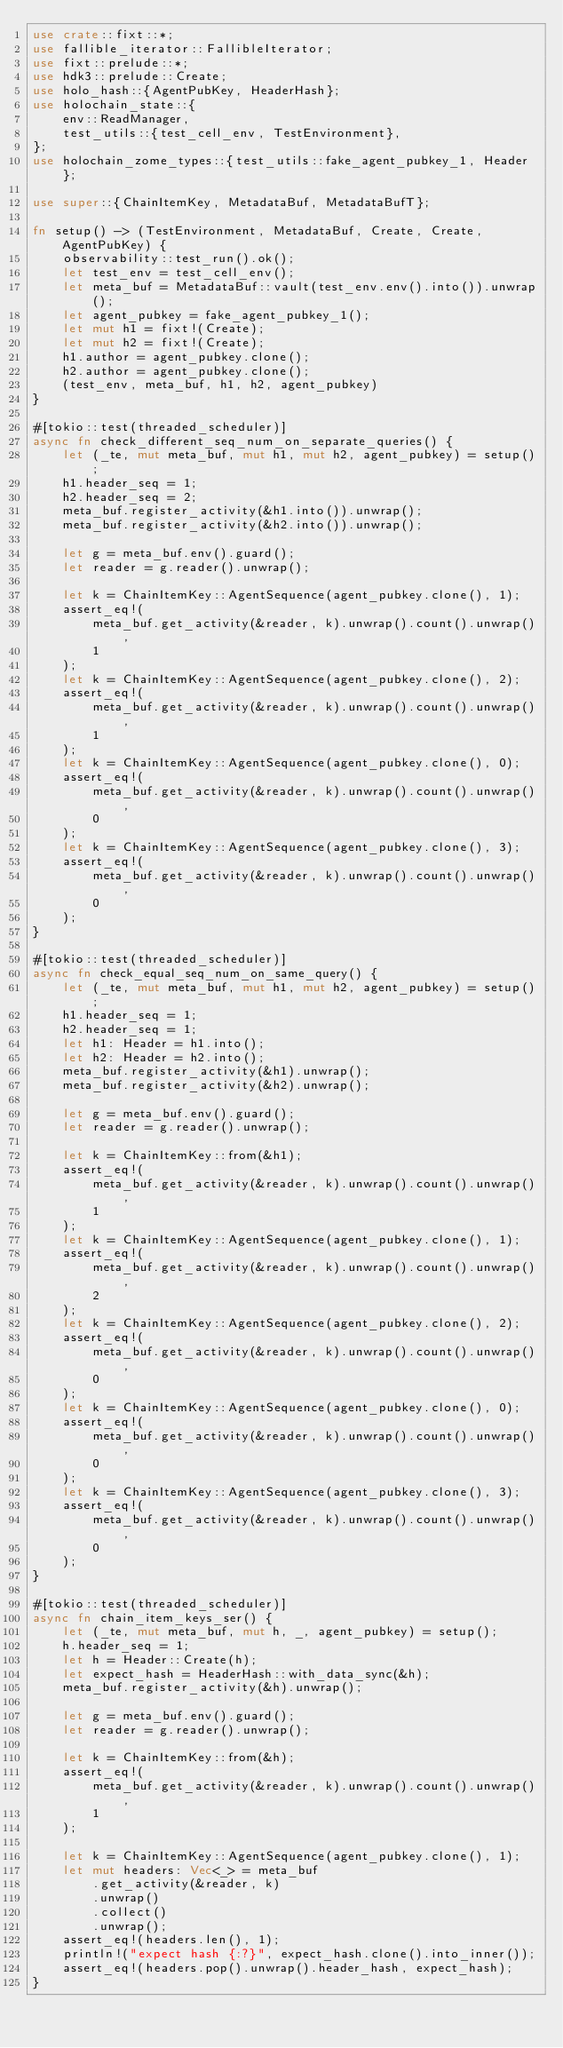<code> <loc_0><loc_0><loc_500><loc_500><_Rust_>use crate::fixt::*;
use fallible_iterator::FallibleIterator;
use fixt::prelude::*;
use hdk3::prelude::Create;
use holo_hash::{AgentPubKey, HeaderHash};
use holochain_state::{
    env::ReadManager,
    test_utils::{test_cell_env, TestEnvironment},
};
use holochain_zome_types::{test_utils::fake_agent_pubkey_1, Header};

use super::{ChainItemKey, MetadataBuf, MetadataBufT};

fn setup() -> (TestEnvironment, MetadataBuf, Create, Create, AgentPubKey) {
    observability::test_run().ok();
    let test_env = test_cell_env();
    let meta_buf = MetadataBuf::vault(test_env.env().into()).unwrap();
    let agent_pubkey = fake_agent_pubkey_1();
    let mut h1 = fixt!(Create);
    let mut h2 = fixt!(Create);
    h1.author = agent_pubkey.clone();
    h2.author = agent_pubkey.clone();
    (test_env, meta_buf, h1, h2, agent_pubkey)
}

#[tokio::test(threaded_scheduler)]
async fn check_different_seq_num_on_separate_queries() {
    let (_te, mut meta_buf, mut h1, mut h2, agent_pubkey) = setup();
    h1.header_seq = 1;
    h2.header_seq = 2;
    meta_buf.register_activity(&h1.into()).unwrap();
    meta_buf.register_activity(&h2.into()).unwrap();

    let g = meta_buf.env().guard();
    let reader = g.reader().unwrap();

    let k = ChainItemKey::AgentSequence(agent_pubkey.clone(), 1);
    assert_eq!(
        meta_buf.get_activity(&reader, k).unwrap().count().unwrap(),
        1
    );
    let k = ChainItemKey::AgentSequence(agent_pubkey.clone(), 2);
    assert_eq!(
        meta_buf.get_activity(&reader, k).unwrap().count().unwrap(),
        1
    );
    let k = ChainItemKey::AgentSequence(agent_pubkey.clone(), 0);
    assert_eq!(
        meta_buf.get_activity(&reader, k).unwrap().count().unwrap(),
        0
    );
    let k = ChainItemKey::AgentSequence(agent_pubkey.clone(), 3);
    assert_eq!(
        meta_buf.get_activity(&reader, k).unwrap().count().unwrap(),
        0
    );
}

#[tokio::test(threaded_scheduler)]
async fn check_equal_seq_num_on_same_query() {
    let (_te, mut meta_buf, mut h1, mut h2, agent_pubkey) = setup();
    h1.header_seq = 1;
    h2.header_seq = 1;
    let h1: Header = h1.into();
    let h2: Header = h2.into();
    meta_buf.register_activity(&h1).unwrap();
    meta_buf.register_activity(&h2).unwrap();

    let g = meta_buf.env().guard();
    let reader = g.reader().unwrap();

    let k = ChainItemKey::from(&h1);
    assert_eq!(
        meta_buf.get_activity(&reader, k).unwrap().count().unwrap(),
        1
    );
    let k = ChainItemKey::AgentSequence(agent_pubkey.clone(), 1);
    assert_eq!(
        meta_buf.get_activity(&reader, k).unwrap().count().unwrap(),
        2
    );
    let k = ChainItemKey::AgentSequence(agent_pubkey.clone(), 2);
    assert_eq!(
        meta_buf.get_activity(&reader, k).unwrap().count().unwrap(),
        0
    );
    let k = ChainItemKey::AgentSequence(agent_pubkey.clone(), 0);
    assert_eq!(
        meta_buf.get_activity(&reader, k).unwrap().count().unwrap(),
        0
    );
    let k = ChainItemKey::AgentSequence(agent_pubkey.clone(), 3);
    assert_eq!(
        meta_buf.get_activity(&reader, k).unwrap().count().unwrap(),
        0
    );
}

#[tokio::test(threaded_scheduler)]
async fn chain_item_keys_ser() {
    let (_te, mut meta_buf, mut h, _, agent_pubkey) = setup();
    h.header_seq = 1;
    let h = Header::Create(h);
    let expect_hash = HeaderHash::with_data_sync(&h);
    meta_buf.register_activity(&h).unwrap();

    let g = meta_buf.env().guard();
    let reader = g.reader().unwrap();

    let k = ChainItemKey::from(&h);
    assert_eq!(
        meta_buf.get_activity(&reader, k).unwrap().count().unwrap(),
        1
    );

    let k = ChainItemKey::AgentSequence(agent_pubkey.clone(), 1);
    let mut headers: Vec<_> = meta_buf
        .get_activity(&reader, k)
        .unwrap()
        .collect()
        .unwrap();
    assert_eq!(headers.len(), 1);
    println!("expect hash {:?}", expect_hash.clone().into_inner());
    assert_eq!(headers.pop().unwrap().header_hash, expect_hash);
}
</code> 